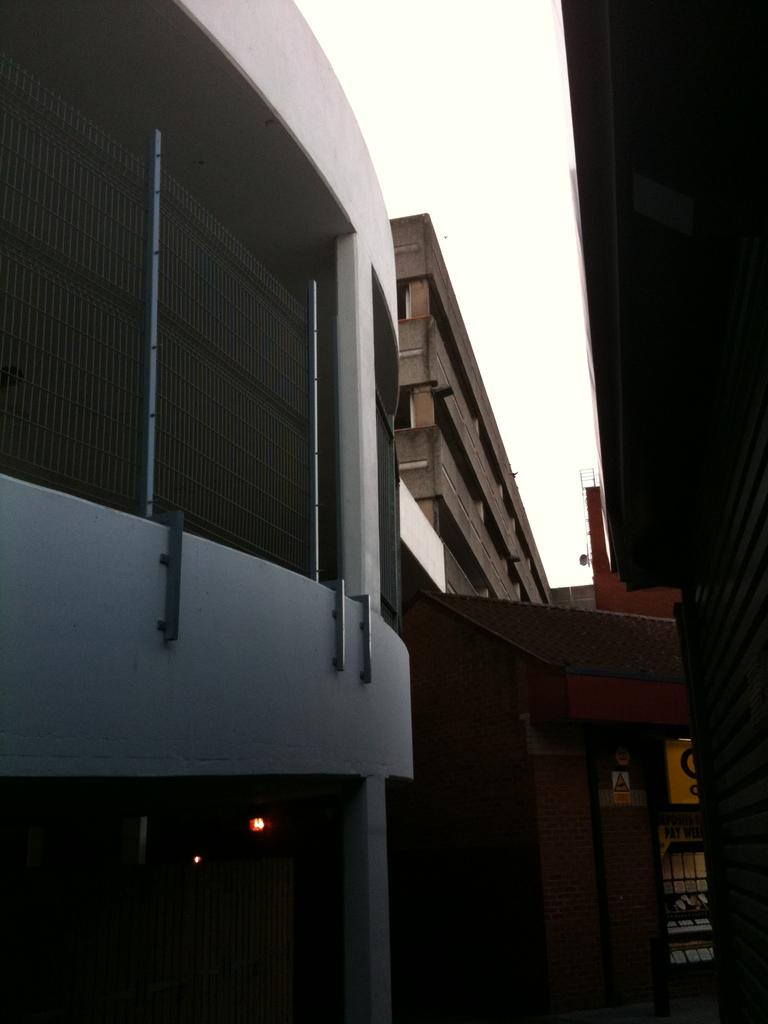Where was the image taken? The image was taken outdoors. What can be seen in the sky in the image? The sky is visible at the top of the image. What type of structures are present in the image? There are buildings in the image. What are some features of the buildings in the image? The buildings have walls, windows, roofs, pillars, and doors. What type of teaching is happening in the image? There is no teaching activity present in the image; it primarily features buildings. How many parcels can be seen being delivered in the image? There are no parcels or delivery activities visible in the image. 